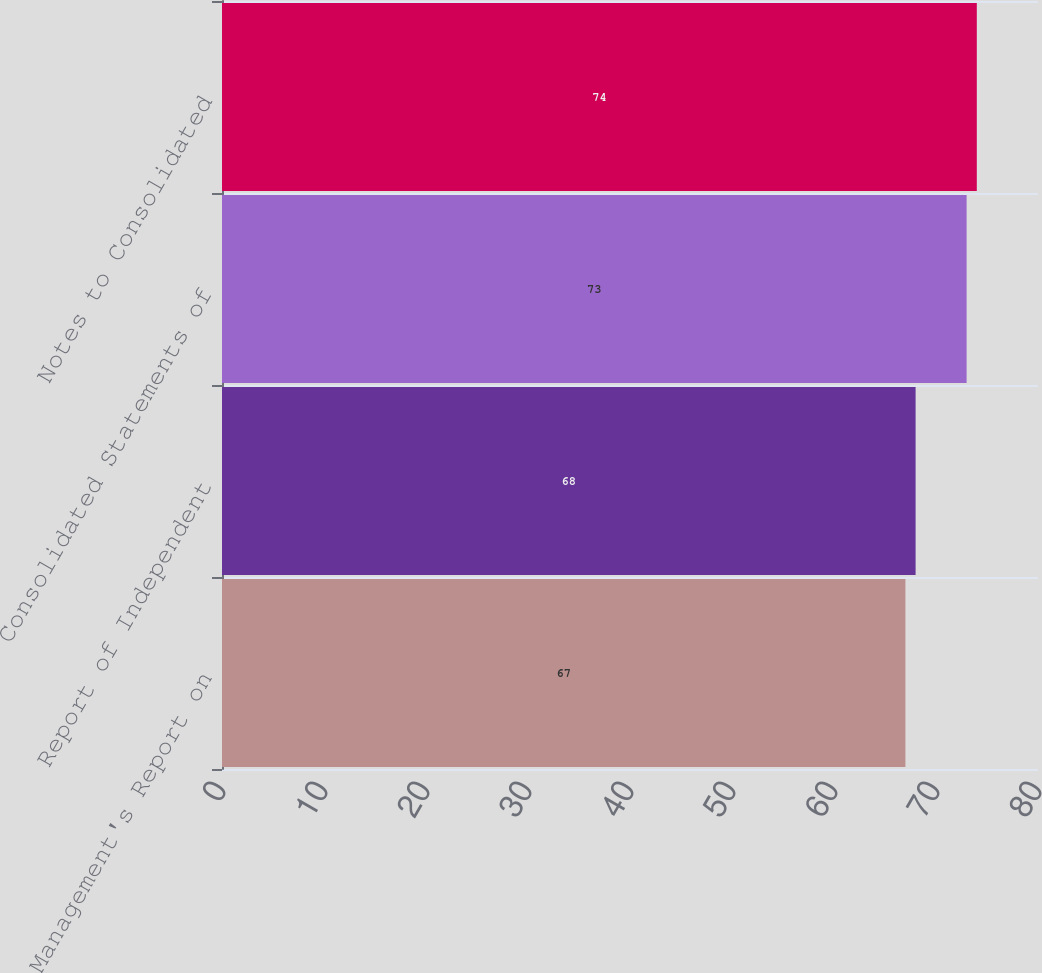<chart> <loc_0><loc_0><loc_500><loc_500><bar_chart><fcel>Management's Report on<fcel>Report of Independent<fcel>Consolidated Statements of<fcel>Notes to Consolidated<nl><fcel>67<fcel>68<fcel>73<fcel>74<nl></chart> 